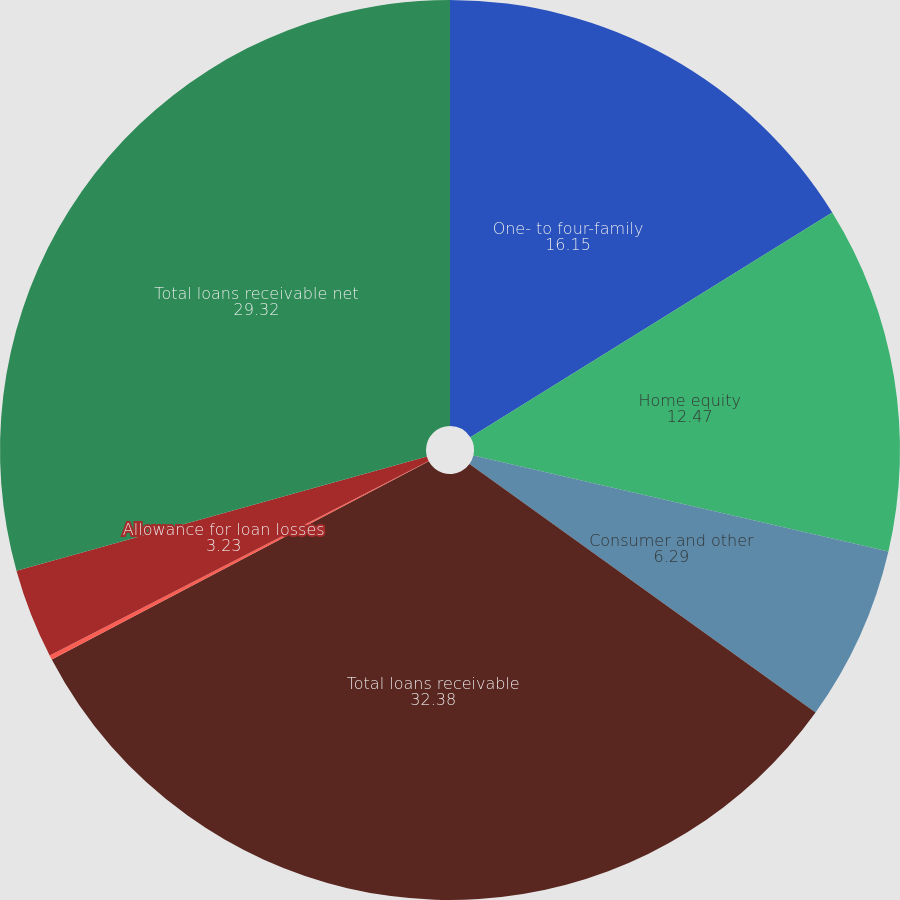<chart> <loc_0><loc_0><loc_500><loc_500><pie_chart><fcel>One- to four-family<fcel>Home equity<fcel>Consumer and other<fcel>Total loans receivable<fcel>Unamortized premiums net<fcel>Allowance for loan losses<fcel>Total loans receivable net<nl><fcel>16.15%<fcel>12.47%<fcel>6.29%<fcel>32.38%<fcel>0.16%<fcel>3.23%<fcel>29.32%<nl></chart> 